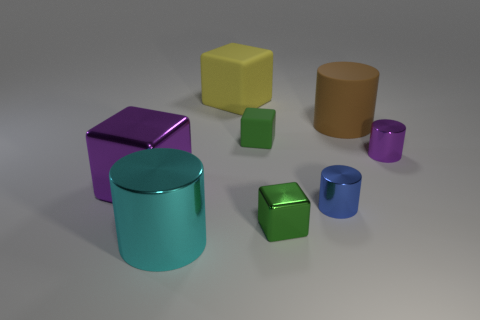Can you describe the lighting direction in this scene? The shadows cast by the objects indicate that the light source is coming from the top left side of the scene, which creates a soft contrast and gives depth to the objects on the surface. 